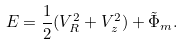Convert formula to latex. <formula><loc_0><loc_0><loc_500><loc_500>E = \frac { 1 } { 2 } ( { V } _ { R } ^ { 2 } + { V } _ { z } ^ { 2 } ) + \tilde { \Phi } _ { m } .</formula> 